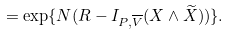<formula> <loc_0><loc_0><loc_500><loc_500>= \exp \{ N ( R - I _ { P , \overline { V } } ( X \wedge \widetilde { X } ) ) \} .</formula> 